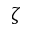Convert formula to latex. <formula><loc_0><loc_0><loc_500><loc_500>\zeta</formula> 